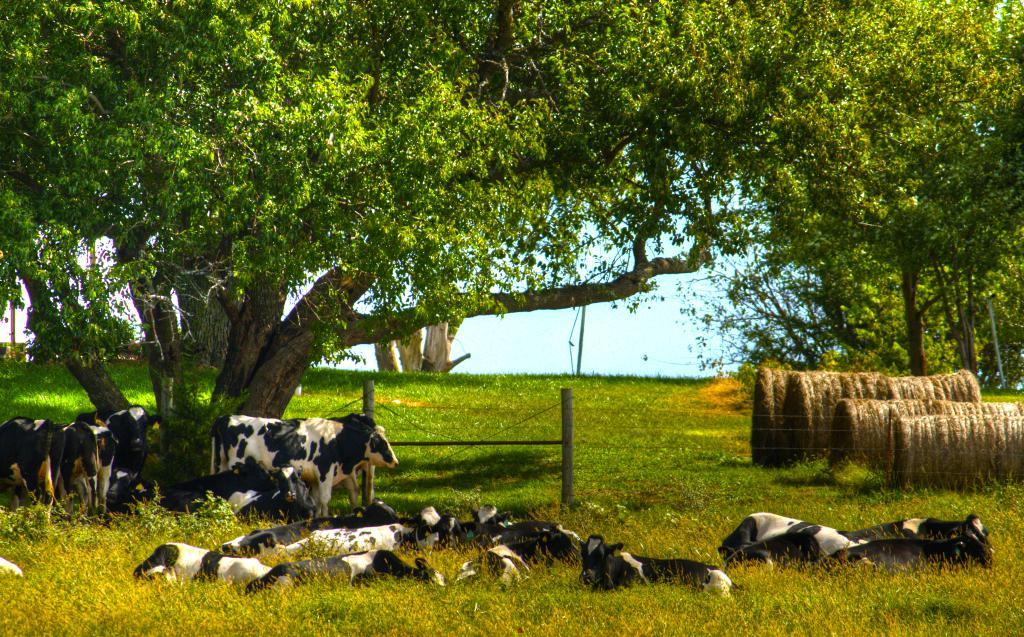What animals can be seen in the image? There are cows in the image. Where are the cows located? The cows are on the grass. What type of vegetation is visible in the image? There are trees visible in the image. How would you describe the condition of the grass in the image? The grass in the image is dry. Is the grass in the image affected by quicksand? There is no indication of quicksand in the image, so it cannot be determined if the grass is affected by it. 